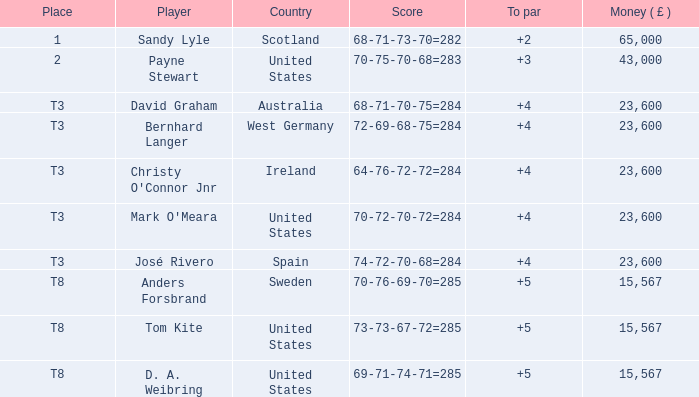What spot is david graham occupying? T3. 